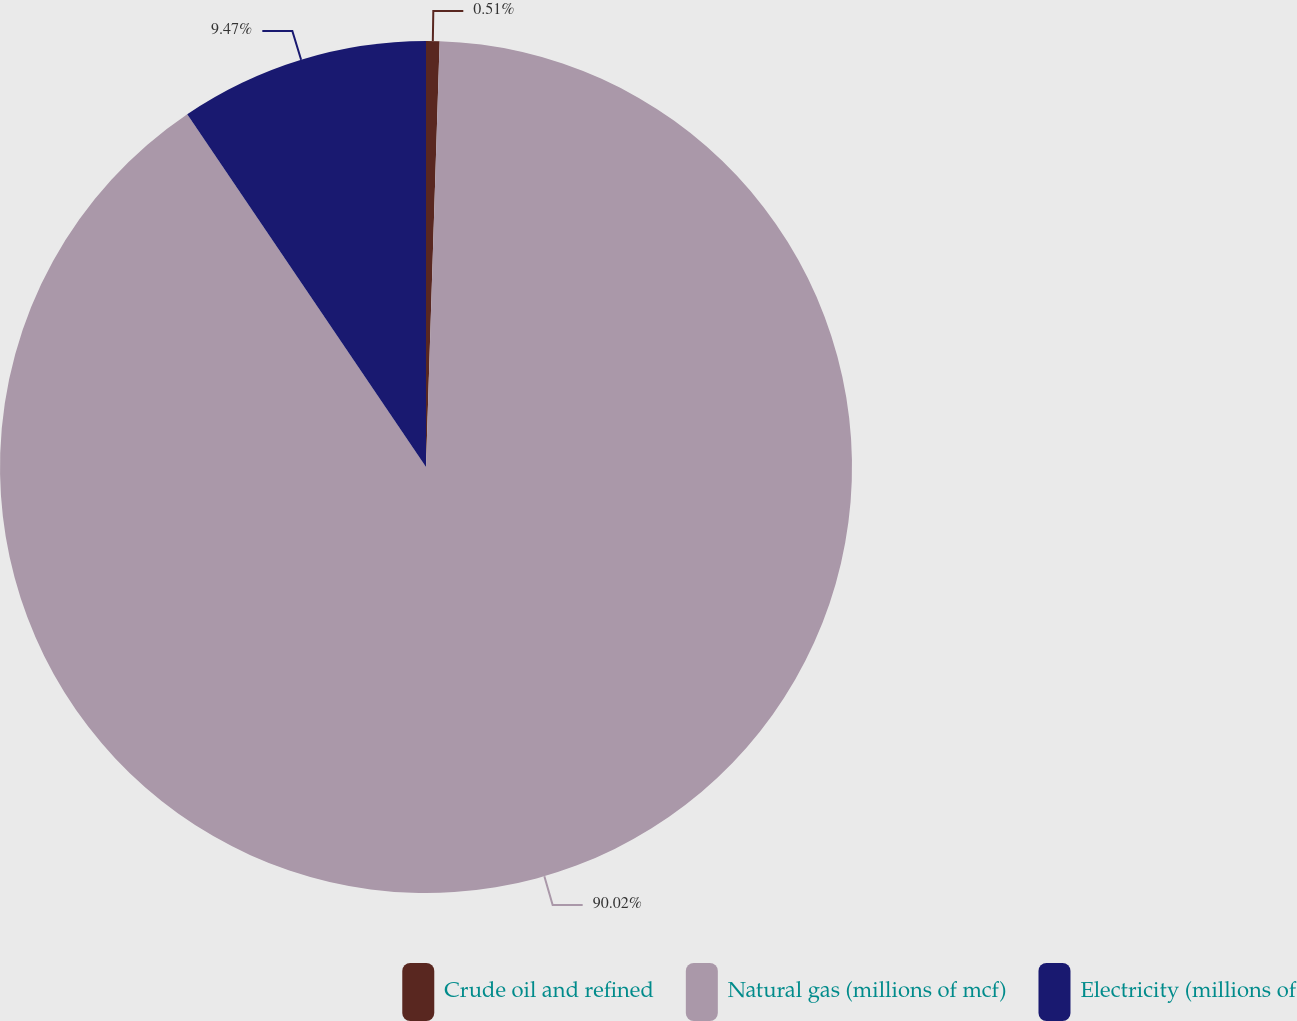<chart> <loc_0><loc_0><loc_500><loc_500><pie_chart><fcel>Crude oil and refined<fcel>Natural gas (millions of mcf)<fcel>Electricity (millions of<nl><fcel>0.51%<fcel>90.02%<fcel>9.47%<nl></chart> 